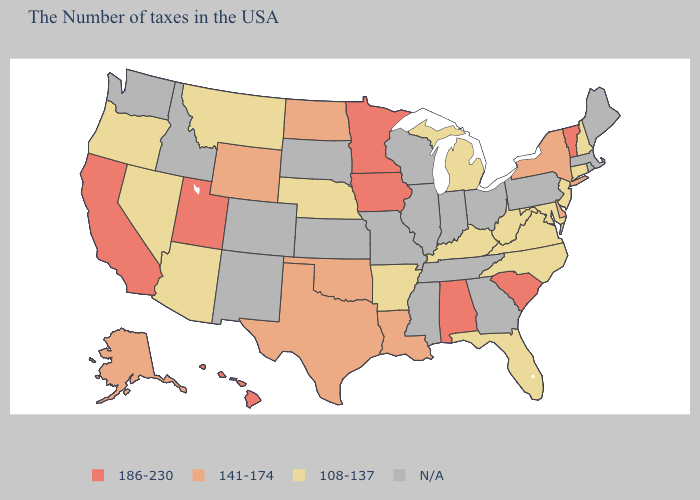Name the states that have a value in the range 141-174?
Short answer required. New York, Delaware, Louisiana, Oklahoma, Texas, North Dakota, Wyoming, Alaska. What is the value of Tennessee?
Write a very short answer. N/A. What is the value of Vermont?
Quick response, please. 186-230. What is the value of Texas?
Give a very brief answer. 141-174. What is the lowest value in states that border Georgia?
Concise answer only. 108-137. What is the value of Missouri?
Concise answer only. N/A. What is the highest value in the USA?
Keep it brief. 186-230. Name the states that have a value in the range N/A?
Give a very brief answer. Maine, Massachusetts, Rhode Island, Pennsylvania, Ohio, Georgia, Indiana, Tennessee, Wisconsin, Illinois, Mississippi, Missouri, Kansas, South Dakota, Colorado, New Mexico, Idaho, Washington. Name the states that have a value in the range 186-230?
Give a very brief answer. Vermont, South Carolina, Alabama, Minnesota, Iowa, Utah, California, Hawaii. Name the states that have a value in the range 186-230?
Give a very brief answer. Vermont, South Carolina, Alabama, Minnesota, Iowa, Utah, California, Hawaii. What is the value of New Jersey?
Short answer required. 108-137. How many symbols are there in the legend?
Quick response, please. 4. 